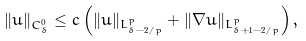Convert formula to latex. <formula><loc_0><loc_0><loc_500><loc_500>\| u \| _ { C ^ { 0 } _ { \delta } } \leq c \left ( \| u \| _ { L ^ { p } _ { \delta - 2 / p } } + \| \nabla u \| _ { L ^ { p } _ { \delta + 1 - 2 / p } } \right ) ,</formula> 